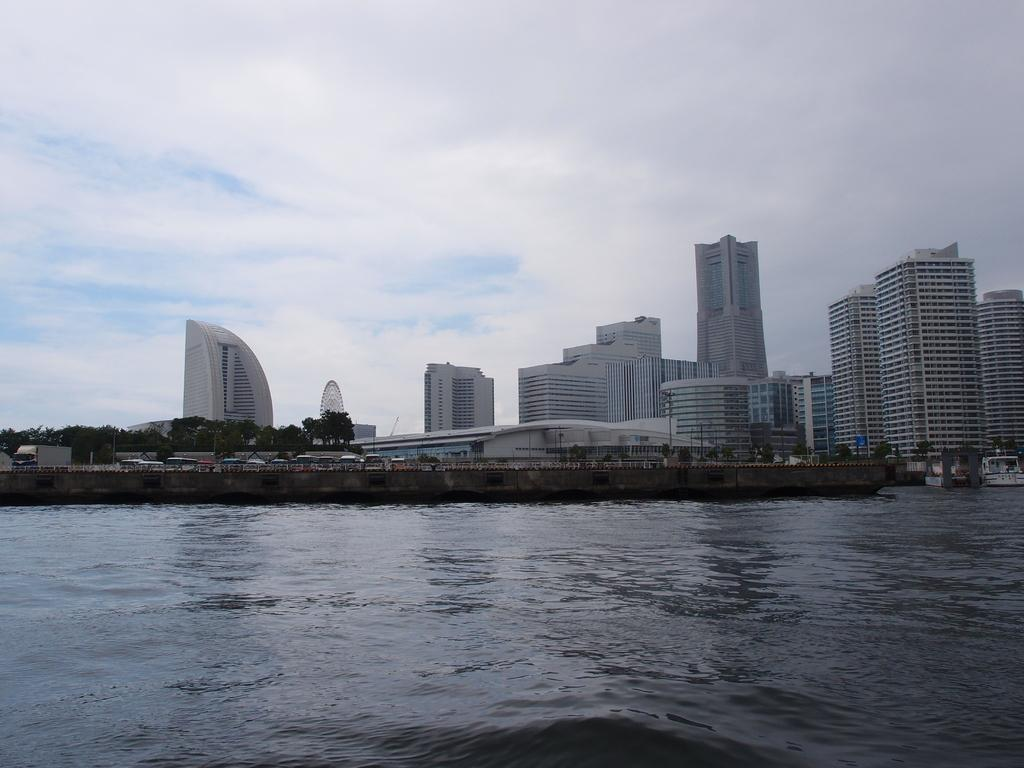What is the primary element visible in the image? There is water in the image. What else can be seen in the image besides the water? There are vehicles on the road, trees and buildings in the background, and the sky is visible with clouds present. Can you describe the road in the image? The road has vehicles on it. What type of structures can be seen in the background of the image? There are buildings in the background of the image. What type of trade is happening between the vehicles in the image? There is no indication of any trade happening between the vehicles in the image. Can you tell me how many times the image has been copied? The image itself has not been copied; it is a single image. 